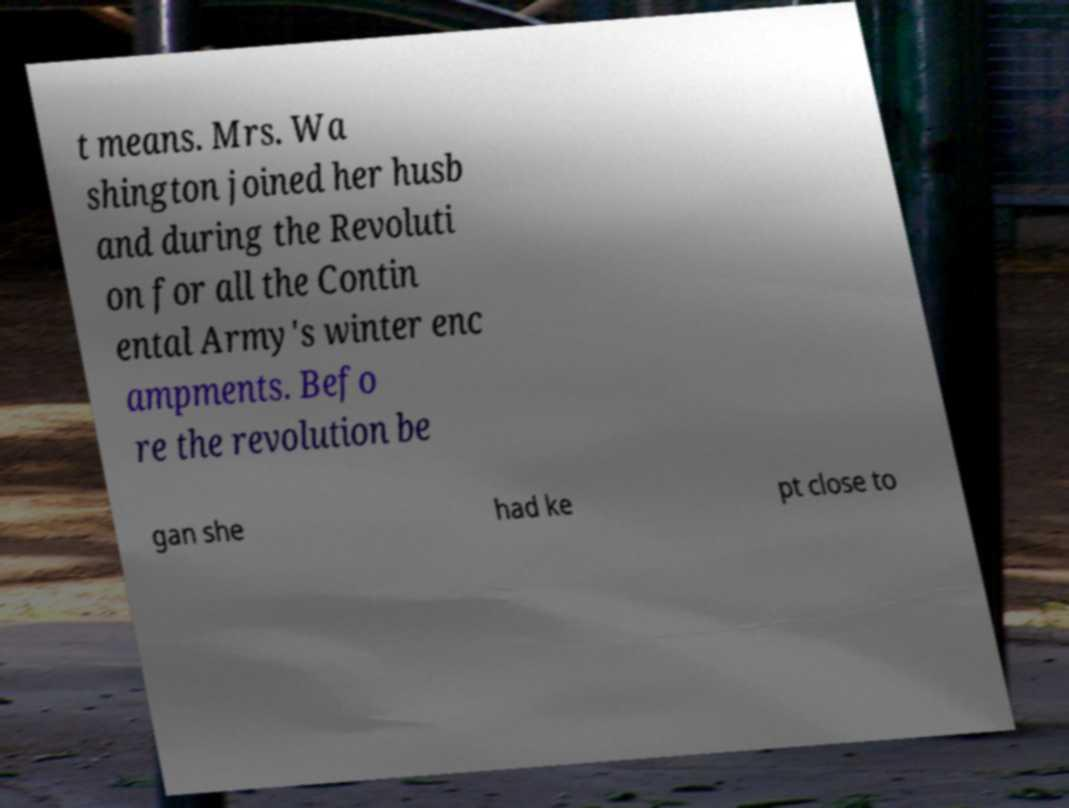Please read and relay the text visible in this image. What does it say? t means. Mrs. Wa shington joined her husb and during the Revoluti on for all the Contin ental Army's winter enc ampments. Befo re the revolution be gan she had ke pt close to 